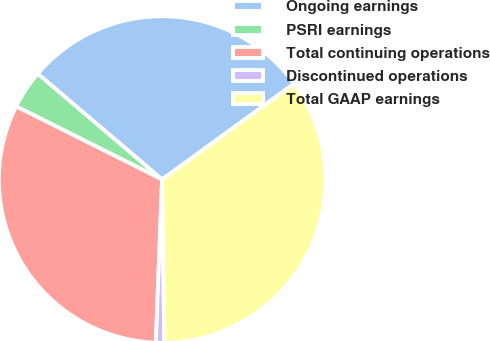Convert chart. <chart><loc_0><loc_0><loc_500><loc_500><pie_chart><fcel>Ongoing earnings<fcel>PSRI earnings<fcel>Total continuing operations<fcel>Discontinued operations<fcel>Total GAAP earnings<nl><fcel>28.79%<fcel>3.82%<fcel>31.78%<fcel>0.83%<fcel>34.77%<nl></chart> 